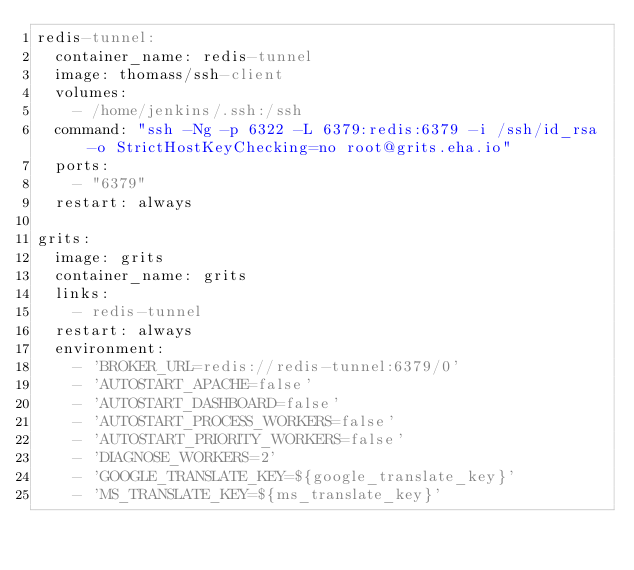<code> <loc_0><loc_0><loc_500><loc_500><_YAML_>redis-tunnel:
  container_name: redis-tunnel
  image: thomass/ssh-client
  volumes:
    - /home/jenkins/.ssh:/ssh
  command: "ssh -Ng -p 6322 -L 6379:redis:6379 -i /ssh/id_rsa -o StrictHostKeyChecking=no root@grits.eha.io"
  ports:
    - "6379"
  restart: always

grits:
  image: grits
  container_name: grits
  links:
    - redis-tunnel
  restart: always
  environment:
    - 'BROKER_URL=redis://redis-tunnel:6379/0'
    - 'AUTOSTART_APACHE=false'
    - 'AUTOSTART_DASHBOARD=false'
    - 'AUTOSTART_PROCESS_WORKERS=false'
    - 'AUTOSTART_PRIORITY_WORKERS=false'
    - 'DIAGNOSE_WORKERS=2'
    - 'GOOGLE_TRANSLATE_KEY=${google_translate_key}'
    - 'MS_TRANSLATE_KEY=${ms_translate_key}'
</code> 